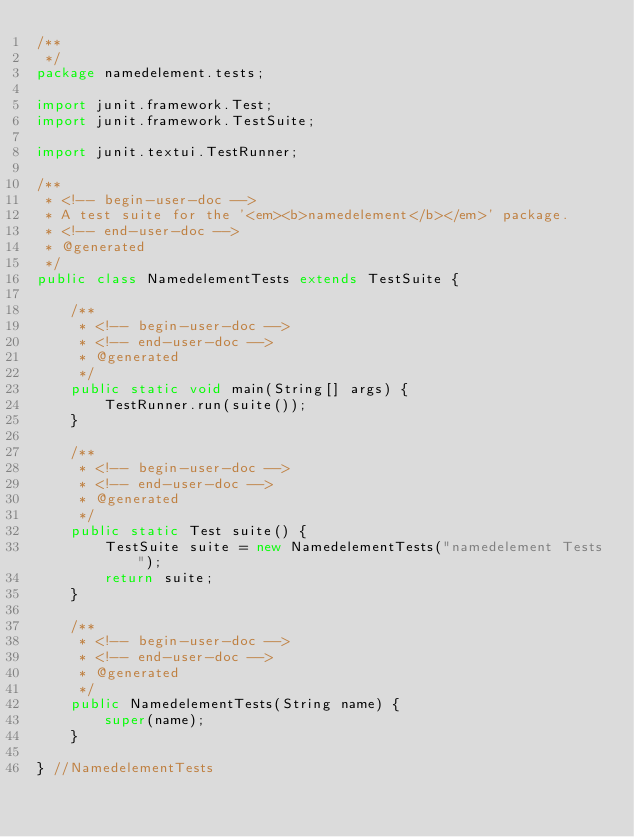Convert code to text. <code><loc_0><loc_0><loc_500><loc_500><_Java_>/**
 */
package namedelement.tests;

import junit.framework.Test;
import junit.framework.TestSuite;

import junit.textui.TestRunner;

/**
 * <!-- begin-user-doc -->
 * A test suite for the '<em><b>namedelement</b></em>' package.
 * <!-- end-user-doc -->
 * @generated
 */
public class NamedelementTests extends TestSuite {

	/**
	 * <!-- begin-user-doc -->
	 * <!-- end-user-doc -->
	 * @generated
	 */
	public static void main(String[] args) {
		TestRunner.run(suite());
	}

	/**
	 * <!-- begin-user-doc -->
	 * <!-- end-user-doc -->
	 * @generated
	 */
	public static Test suite() {
		TestSuite suite = new NamedelementTests("namedelement Tests");
		return suite;
	}

	/**
	 * <!-- begin-user-doc -->
	 * <!-- end-user-doc -->
	 * @generated
	 */
	public NamedelementTests(String name) {
		super(name);
	}

} //NamedelementTests
</code> 